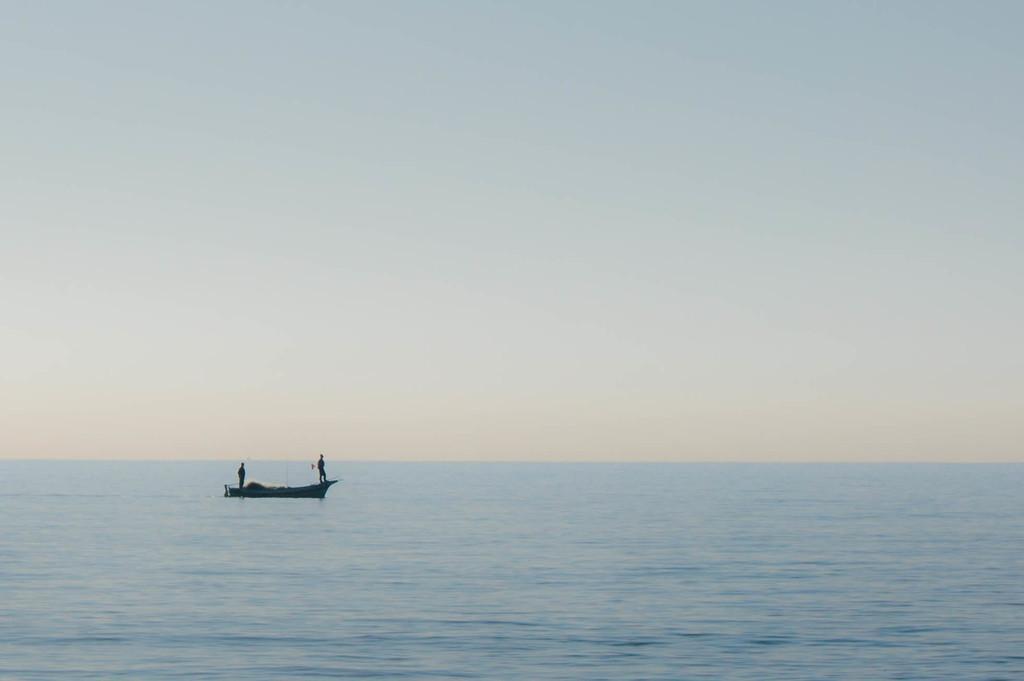Can you describe this image briefly? In this picture we can see the two men standing in the boat. In the front bottom side there is a sea water. On the top there is a sky. 